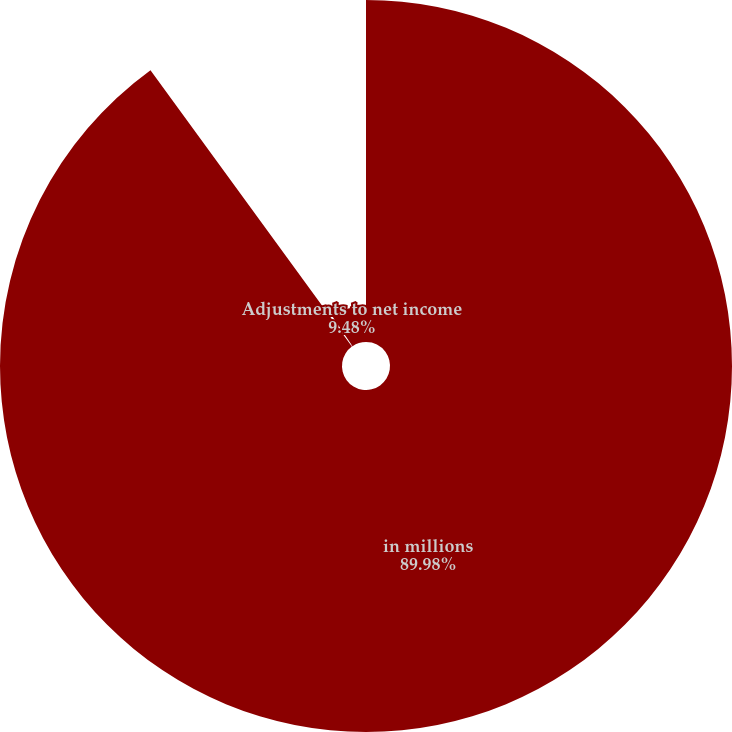Convert chart to OTSL. <chart><loc_0><loc_0><loc_500><loc_500><pie_chart><fcel>in millions<fcel>Adjustments to operating<fcel>Adjustments to net income<nl><fcel>89.97%<fcel>0.54%<fcel>9.48%<nl></chart> 